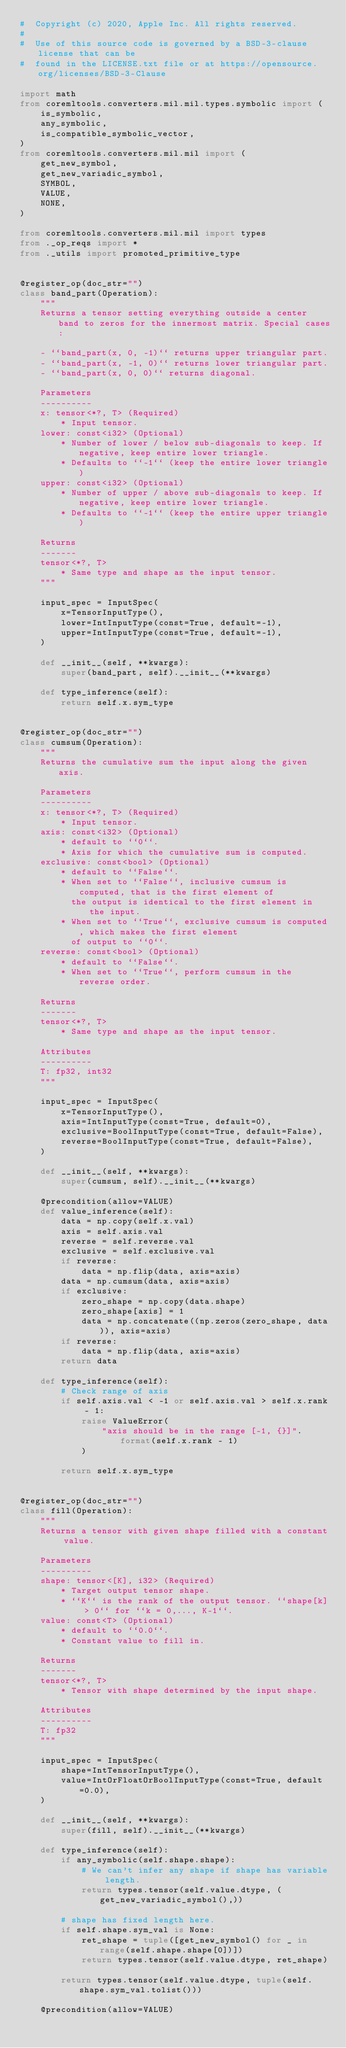<code> <loc_0><loc_0><loc_500><loc_500><_Python_>#  Copyright (c) 2020, Apple Inc. All rights reserved.
#
#  Use of this source code is governed by a BSD-3-clause license that can be
#  found in the LICENSE.txt file or at https://opensource.org/licenses/BSD-3-Clause

import math
from coremltools.converters.mil.mil.types.symbolic import (
    is_symbolic,
    any_symbolic,
    is_compatible_symbolic_vector,
)
from coremltools.converters.mil.mil import (
    get_new_symbol,
    get_new_variadic_symbol,
    SYMBOL,
    VALUE,
    NONE,
)

from coremltools.converters.mil.mil import types
from ._op_reqs import *
from ._utils import promoted_primitive_type


@register_op(doc_str="")
class band_part(Operation):
    """
    Returns a tensor setting everything outside a center band to zeros for the innermost matrix. Special cases:

    - ``band_part(x, 0, -1)`` returns upper triangular part.
    - ``band_part(x, -1, 0)`` returns lower triangular part.
    - ``band_part(x, 0, 0)`` returns diagonal.

    Parameters
    ----------
    x: tensor<*?, T> (Required)
        * Input tensor.
    lower: const<i32> (Optional)
        * Number of lower / below sub-diagonals to keep. If negative, keep entire lower triangle.
        * Defaults to ``-1`` (keep the entire lower triangle)
    upper: const<i32> (Optional)
        * Number of upper / above sub-diagonals to keep. If negative, keep entire lower triangle.
        * Defaults to ``-1`` (keep the entire upper triangle)

    Returns
    -------
    tensor<*?, T>
        * Same type and shape as the input tensor.
    """

    input_spec = InputSpec(
        x=TensorInputType(),
        lower=IntInputType(const=True, default=-1),
        upper=IntInputType(const=True, default=-1),
    )

    def __init__(self, **kwargs):
        super(band_part, self).__init__(**kwargs)

    def type_inference(self):
        return self.x.sym_type


@register_op(doc_str="")
class cumsum(Operation):
    """
    Returns the cumulative sum the input along the given axis.

    Parameters
    ----------
    x: tensor<*?, T> (Required)
        * Input tensor.
    axis: const<i32> (Optional)
        * default to ``0``.
        * Axis for which the cumulative sum is computed.
    exclusive: const<bool> (Optional)
        * default to ``False``.
        * When set to ``False``, inclusive cumsum is computed, that is the first element of
          the output is identical to the first element in the input.
        * When set to ``True``, exclusive cumsum is computed, which makes the first element
          of output to ``0``.
    reverse: const<bool> (Optional)
        * default to ``False``.
        * When set to ``True``, perform cumsum in the reverse order.

    Returns
    -------
    tensor<*?, T>
        * Same type and shape as the input tensor.

    Attributes
    ----------
    T: fp32, int32
    """

    input_spec = InputSpec(
        x=TensorInputType(),
        axis=IntInputType(const=True, default=0),
        exclusive=BoolInputType(const=True, default=False),
        reverse=BoolInputType(const=True, default=False),
    )

    def __init__(self, **kwargs):
        super(cumsum, self).__init__(**kwargs)

    @precondition(allow=VALUE)
    def value_inference(self):
        data = np.copy(self.x.val)
        axis = self.axis.val
        reverse = self.reverse.val
        exclusive = self.exclusive.val
        if reverse:
            data = np.flip(data, axis=axis)
        data = np.cumsum(data, axis=axis)
        if exclusive:
            zero_shape = np.copy(data.shape)
            zero_shape[axis] = 1
            data = np.concatenate((np.zeros(zero_shape, data)), axis=axis)
        if reverse:
            data = np.flip(data, axis=axis)
        return data

    def type_inference(self):
        # Check range of axis
        if self.axis.val < -1 or self.axis.val > self.x.rank - 1:
            raise ValueError(
                "axis should be in the range [-1, {}]".format(self.x.rank - 1)
            )

        return self.x.sym_type


@register_op(doc_str="")
class fill(Operation):
    """
    Returns a tensor with given shape filled with a constant value.

    Parameters
    ----------
    shape: tensor<[K], i32> (Required)
        * Target output tensor shape.
        * ``K`` is the rank of the output tensor. ``shape[k] > 0`` for ``k = 0,..., K-1``.
    value: const<T> (Optional)
        * default to ``0.0``.
        * Constant value to fill in.

    Returns
    -------
    tensor<*?, T>
        * Tensor with shape determined by the input shape.

    Attributes
    ----------
    T: fp32
    """

    input_spec = InputSpec(
        shape=IntTensorInputType(),
        value=IntOrFloatOrBoolInputType(const=True, default=0.0),
    )

    def __init__(self, **kwargs):
        super(fill, self).__init__(**kwargs)

    def type_inference(self):
        if any_symbolic(self.shape.shape):
            # We can't infer any shape if shape has variable length.
            return types.tensor(self.value.dtype, (get_new_variadic_symbol(),))

        # shape has fixed length here.
        if self.shape.sym_val is None:
            ret_shape = tuple([get_new_symbol() for _ in range(self.shape.shape[0])])
            return types.tensor(self.value.dtype, ret_shape)

        return types.tensor(self.value.dtype, tuple(self.shape.sym_val.tolist()))

    @precondition(allow=VALUE)</code> 